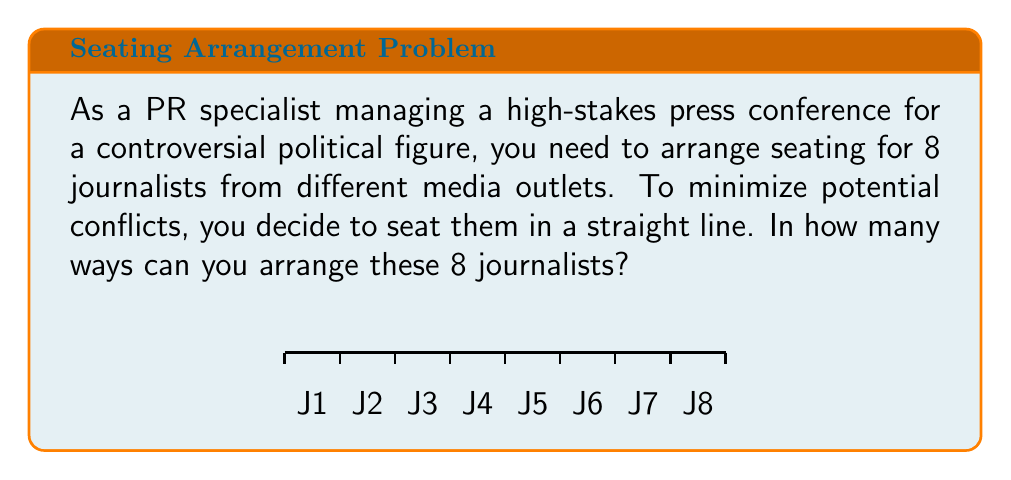What is the answer to this math problem? To solve this problem, we can use the concept of permutations from discrete mathematics. Here's the step-by-step solution:

1) We have 8 distinct journalists (J1, J2, ..., J8) to be seated in a line.

2) This is a permutation problem because the order matters (different seating arrangements are considered distinct).

3) For permutations without repetition of n distinct objects, we use the formula:

   $$P(n) = n!$$

   Where $n!$ represents the factorial of n.

4) In this case, $n = 8$, so we need to calculate $8!$

5) Let's expand this:
   $$8! = 8 \times 7 \times 6 \times 5 \times 4 \times 3 \times 2 \times 1$$

6) Calculating this out:
   $$8! = 40,320$$

Therefore, there are 40,320 possible ways to arrange 8 journalists in a line for the press conference.
Answer: $40,320$ 